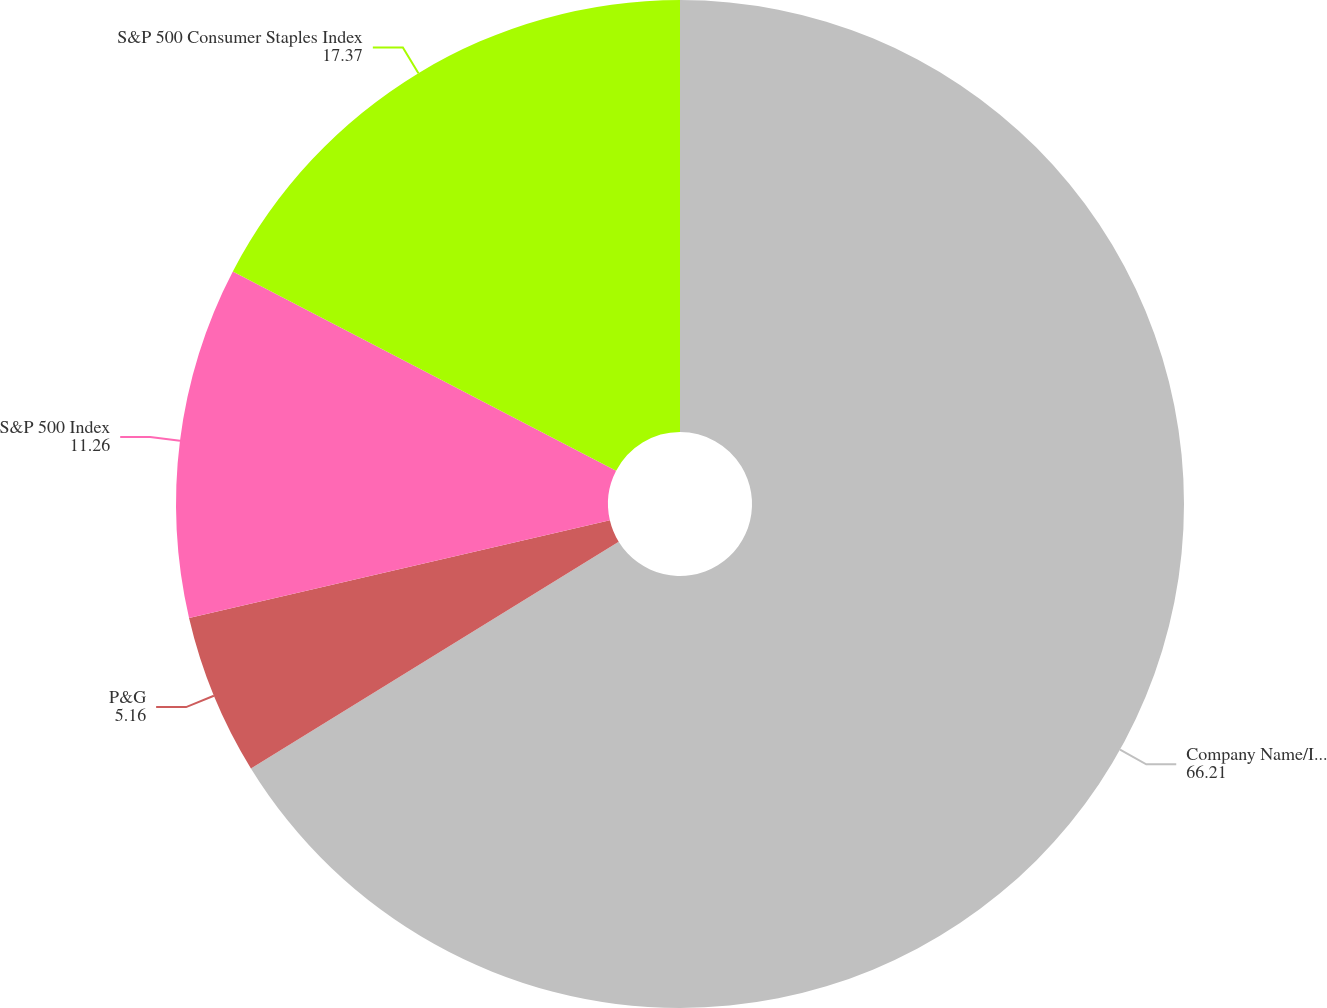Convert chart to OTSL. <chart><loc_0><loc_0><loc_500><loc_500><pie_chart><fcel>Company Name/Index<fcel>P&G<fcel>S&P 500 Index<fcel>S&P 500 Consumer Staples Index<nl><fcel>66.21%<fcel>5.16%<fcel>11.26%<fcel>17.37%<nl></chart> 